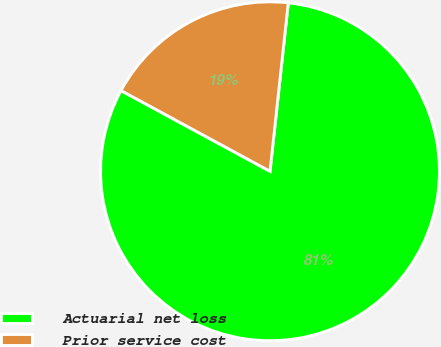Convert chart. <chart><loc_0><loc_0><loc_500><loc_500><pie_chart><fcel>Actuarial net loss<fcel>Prior service cost<nl><fcel>81.18%<fcel>18.82%<nl></chart> 